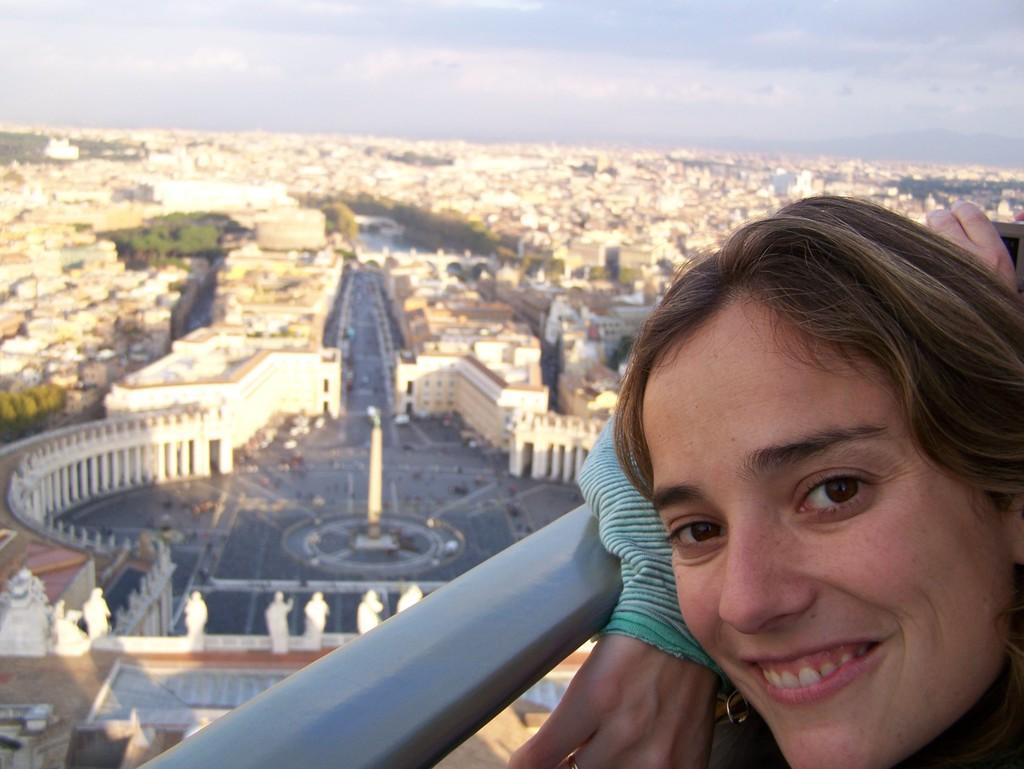How would you summarize this image in a sentence or two? In this picture I can see few buildings and I can see trees and I can see a woman on the right side with a smile on her face and looks like a memorial in the middle of the picture and I can see few statues and I can see a cloudy sky. 